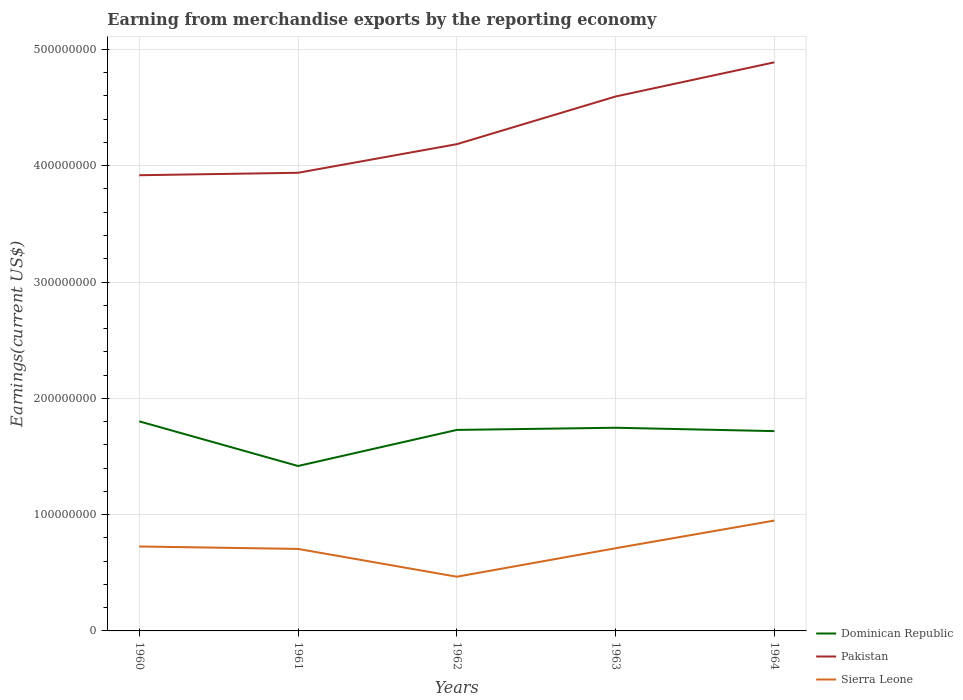How many different coloured lines are there?
Give a very brief answer. 3. Does the line corresponding to Sierra Leone intersect with the line corresponding to Pakistan?
Your response must be concise. No. Across all years, what is the maximum amount earned from merchandise exports in Sierra Leone?
Your response must be concise. 4.66e+07. In which year was the amount earned from merchandise exports in Dominican Republic maximum?
Your answer should be compact. 1961. What is the total amount earned from merchandise exports in Pakistan in the graph?
Keep it short and to the point. -2.67e+07. What is the difference between the highest and the second highest amount earned from merchandise exports in Sierra Leone?
Your response must be concise. 4.83e+07. What is the difference between the highest and the lowest amount earned from merchandise exports in Dominican Republic?
Offer a terse response. 4. Is the amount earned from merchandise exports in Dominican Republic strictly greater than the amount earned from merchandise exports in Sierra Leone over the years?
Offer a terse response. No. How many lines are there?
Offer a very short reply. 3. Does the graph contain any zero values?
Keep it short and to the point. No. How many legend labels are there?
Ensure brevity in your answer.  3. How are the legend labels stacked?
Provide a short and direct response. Vertical. What is the title of the graph?
Offer a very short reply. Earning from merchandise exports by the reporting economy. Does "Small states" appear as one of the legend labels in the graph?
Offer a very short reply. No. What is the label or title of the Y-axis?
Your answer should be very brief. Earnings(current US$). What is the Earnings(current US$) in Dominican Republic in 1960?
Your answer should be very brief. 1.80e+08. What is the Earnings(current US$) of Pakistan in 1960?
Offer a terse response. 3.92e+08. What is the Earnings(current US$) in Sierra Leone in 1960?
Make the answer very short. 7.26e+07. What is the Earnings(current US$) in Dominican Republic in 1961?
Give a very brief answer. 1.42e+08. What is the Earnings(current US$) in Pakistan in 1961?
Provide a short and direct response. 3.94e+08. What is the Earnings(current US$) of Sierra Leone in 1961?
Keep it short and to the point. 7.05e+07. What is the Earnings(current US$) of Dominican Republic in 1962?
Ensure brevity in your answer.  1.73e+08. What is the Earnings(current US$) in Pakistan in 1962?
Ensure brevity in your answer.  4.18e+08. What is the Earnings(current US$) in Sierra Leone in 1962?
Provide a short and direct response. 4.66e+07. What is the Earnings(current US$) in Dominican Republic in 1963?
Offer a very short reply. 1.75e+08. What is the Earnings(current US$) in Pakistan in 1963?
Your answer should be compact. 4.60e+08. What is the Earnings(current US$) in Sierra Leone in 1963?
Provide a short and direct response. 7.11e+07. What is the Earnings(current US$) in Dominican Republic in 1964?
Offer a terse response. 1.72e+08. What is the Earnings(current US$) in Pakistan in 1964?
Offer a terse response. 4.89e+08. What is the Earnings(current US$) of Sierra Leone in 1964?
Provide a succinct answer. 9.49e+07. Across all years, what is the maximum Earnings(current US$) in Dominican Republic?
Your response must be concise. 1.80e+08. Across all years, what is the maximum Earnings(current US$) in Pakistan?
Keep it short and to the point. 4.89e+08. Across all years, what is the maximum Earnings(current US$) in Sierra Leone?
Your answer should be compact. 9.49e+07. Across all years, what is the minimum Earnings(current US$) of Dominican Republic?
Provide a short and direct response. 1.42e+08. Across all years, what is the minimum Earnings(current US$) of Pakistan?
Your response must be concise. 3.92e+08. Across all years, what is the minimum Earnings(current US$) in Sierra Leone?
Offer a very short reply. 4.66e+07. What is the total Earnings(current US$) in Dominican Republic in the graph?
Keep it short and to the point. 8.41e+08. What is the total Earnings(current US$) in Pakistan in the graph?
Offer a very short reply. 2.15e+09. What is the total Earnings(current US$) of Sierra Leone in the graph?
Provide a succinct answer. 3.56e+08. What is the difference between the Earnings(current US$) of Dominican Republic in 1960 and that in 1961?
Ensure brevity in your answer.  3.84e+07. What is the difference between the Earnings(current US$) of Pakistan in 1960 and that in 1961?
Provide a succinct answer. -2.10e+06. What is the difference between the Earnings(current US$) in Sierra Leone in 1960 and that in 1961?
Ensure brevity in your answer.  2.10e+06. What is the difference between the Earnings(current US$) in Dominican Republic in 1960 and that in 1962?
Make the answer very short. 7.38e+06. What is the difference between the Earnings(current US$) in Pakistan in 1960 and that in 1962?
Provide a succinct answer. -2.67e+07. What is the difference between the Earnings(current US$) in Sierra Leone in 1960 and that in 1962?
Ensure brevity in your answer.  2.60e+07. What is the difference between the Earnings(current US$) of Dominican Republic in 1960 and that in 1963?
Provide a succinct answer. 5.52e+06. What is the difference between the Earnings(current US$) in Pakistan in 1960 and that in 1963?
Offer a very short reply. -6.77e+07. What is the difference between the Earnings(current US$) of Sierra Leone in 1960 and that in 1963?
Your response must be concise. 1.50e+06. What is the difference between the Earnings(current US$) in Dominican Republic in 1960 and that in 1964?
Your response must be concise. 8.41e+06. What is the difference between the Earnings(current US$) of Pakistan in 1960 and that in 1964?
Your answer should be compact. -9.71e+07. What is the difference between the Earnings(current US$) in Sierra Leone in 1960 and that in 1964?
Your answer should be very brief. -2.23e+07. What is the difference between the Earnings(current US$) in Dominican Republic in 1961 and that in 1962?
Your answer should be compact. -3.10e+07. What is the difference between the Earnings(current US$) in Pakistan in 1961 and that in 1962?
Give a very brief answer. -2.46e+07. What is the difference between the Earnings(current US$) in Sierra Leone in 1961 and that in 1962?
Ensure brevity in your answer.  2.39e+07. What is the difference between the Earnings(current US$) of Dominican Republic in 1961 and that in 1963?
Provide a short and direct response. -3.29e+07. What is the difference between the Earnings(current US$) in Pakistan in 1961 and that in 1963?
Your answer should be very brief. -6.56e+07. What is the difference between the Earnings(current US$) in Sierra Leone in 1961 and that in 1963?
Your answer should be very brief. -6.00e+05. What is the difference between the Earnings(current US$) of Dominican Republic in 1961 and that in 1964?
Make the answer very short. -3.00e+07. What is the difference between the Earnings(current US$) in Pakistan in 1961 and that in 1964?
Your answer should be compact. -9.50e+07. What is the difference between the Earnings(current US$) of Sierra Leone in 1961 and that in 1964?
Ensure brevity in your answer.  -2.44e+07. What is the difference between the Earnings(current US$) in Dominican Republic in 1962 and that in 1963?
Your response must be concise. -1.86e+06. What is the difference between the Earnings(current US$) of Pakistan in 1962 and that in 1963?
Make the answer very short. -4.10e+07. What is the difference between the Earnings(current US$) in Sierra Leone in 1962 and that in 1963?
Your answer should be compact. -2.45e+07. What is the difference between the Earnings(current US$) in Dominican Republic in 1962 and that in 1964?
Offer a very short reply. 1.03e+06. What is the difference between the Earnings(current US$) in Pakistan in 1962 and that in 1964?
Provide a short and direct response. -7.04e+07. What is the difference between the Earnings(current US$) in Sierra Leone in 1962 and that in 1964?
Provide a succinct answer. -4.83e+07. What is the difference between the Earnings(current US$) of Dominican Republic in 1963 and that in 1964?
Offer a terse response. 2.89e+06. What is the difference between the Earnings(current US$) in Pakistan in 1963 and that in 1964?
Offer a terse response. -2.94e+07. What is the difference between the Earnings(current US$) of Sierra Leone in 1963 and that in 1964?
Keep it short and to the point. -2.38e+07. What is the difference between the Earnings(current US$) in Dominican Republic in 1960 and the Earnings(current US$) in Pakistan in 1961?
Your answer should be compact. -2.14e+08. What is the difference between the Earnings(current US$) of Dominican Republic in 1960 and the Earnings(current US$) of Sierra Leone in 1961?
Offer a terse response. 1.10e+08. What is the difference between the Earnings(current US$) in Pakistan in 1960 and the Earnings(current US$) in Sierra Leone in 1961?
Provide a short and direct response. 3.21e+08. What is the difference between the Earnings(current US$) of Dominican Republic in 1960 and the Earnings(current US$) of Pakistan in 1962?
Provide a succinct answer. -2.38e+08. What is the difference between the Earnings(current US$) of Dominican Republic in 1960 and the Earnings(current US$) of Sierra Leone in 1962?
Your response must be concise. 1.34e+08. What is the difference between the Earnings(current US$) of Pakistan in 1960 and the Earnings(current US$) of Sierra Leone in 1962?
Your answer should be very brief. 3.45e+08. What is the difference between the Earnings(current US$) in Dominican Republic in 1960 and the Earnings(current US$) in Pakistan in 1963?
Ensure brevity in your answer.  -2.79e+08. What is the difference between the Earnings(current US$) in Dominican Republic in 1960 and the Earnings(current US$) in Sierra Leone in 1963?
Offer a terse response. 1.09e+08. What is the difference between the Earnings(current US$) of Pakistan in 1960 and the Earnings(current US$) of Sierra Leone in 1963?
Your answer should be very brief. 3.21e+08. What is the difference between the Earnings(current US$) in Dominican Republic in 1960 and the Earnings(current US$) in Pakistan in 1964?
Provide a succinct answer. -3.09e+08. What is the difference between the Earnings(current US$) of Dominican Republic in 1960 and the Earnings(current US$) of Sierra Leone in 1964?
Provide a short and direct response. 8.53e+07. What is the difference between the Earnings(current US$) of Pakistan in 1960 and the Earnings(current US$) of Sierra Leone in 1964?
Provide a succinct answer. 2.97e+08. What is the difference between the Earnings(current US$) in Dominican Republic in 1961 and the Earnings(current US$) in Pakistan in 1962?
Make the answer very short. -2.77e+08. What is the difference between the Earnings(current US$) in Dominican Republic in 1961 and the Earnings(current US$) in Sierra Leone in 1962?
Give a very brief answer. 9.52e+07. What is the difference between the Earnings(current US$) in Pakistan in 1961 and the Earnings(current US$) in Sierra Leone in 1962?
Make the answer very short. 3.47e+08. What is the difference between the Earnings(current US$) in Dominican Republic in 1961 and the Earnings(current US$) in Pakistan in 1963?
Provide a short and direct response. -3.18e+08. What is the difference between the Earnings(current US$) of Dominican Republic in 1961 and the Earnings(current US$) of Sierra Leone in 1963?
Offer a very short reply. 7.07e+07. What is the difference between the Earnings(current US$) of Pakistan in 1961 and the Earnings(current US$) of Sierra Leone in 1963?
Keep it short and to the point. 3.23e+08. What is the difference between the Earnings(current US$) in Dominican Republic in 1961 and the Earnings(current US$) in Pakistan in 1964?
Your answer should be very brief. -3.47e+08. What is the difference between the Earnings(current US$) in Dominican Republic in 1961 and the Earnings(current US$) in Sierra Leone in 1964?
Your answer should be compact. 4.69e+07. What is the difference between the Earnings(current US$) of Pakistan in 1961 and the Earnings(current US$) of Sierra Leone in 1964?
Provide a succinct answer. 2.99e+08. What is the difference between the Earnings(current US$) in Dominican Republic in 1962 and the Earnings(current US$) in Pakistan in 1963?
Your answer should be compact. -2.87e+08. What is the difference between the Earnings(current US$) of Dominican Republic in 1962 and the Earnings(current US$) of Sierra Leone in 1963?
Your answer should be very brief. 1.02e+08. What is the difference between the Earnings(current US$) in Pakistan in 1962 and the Earnings(current US$) in Sierra Leone in 1963?
Provide a short and direct response. 3.47e+08. What is the difference between the Earnings(current US$) in Dominican Republic in 1962 and the Earnings(current US$) in Pakistan in 1964?
Make the answer very short. -3.16e+08. What is the difference between the Earnings(current US$) of Dominican Republic in 1962 and the Earnings(current US$) of Sierra Leone in 1964?
Make the answer very short. 7.79e+07. What is the difference between the Earnings(current US$) of Pakistan in 1962 and the Earnings(current US$) of Sierra Leone in 1964?
Offer a terse response. 3.24e+08. What is the difference between the Earnings(current US$) of Dominican Republic in 1963 and the Earnings(current US$) of Pakistan in 1964?
Offer a terse response. -3.14e+08. What is the difference between the Earnings(current US$) of Dominican Republic in 1963 and the Earnings(current US$) of Sierra Leone in 1964?
Ensure brevity in your answer.  7.98e+07. What is the difference between the Earnings(current US$) of Pakistan in 1963 and the Earnings(current US$) of Sierra Leone in 1964?
Your response must be concise. 3.65e+08. What is the average Earnings(current US$) of Dominican Republic per year?
Offer a terse response. 1.68e+08. What is the average Earnings(current US$) of Pakistan per year?
Provide a short and direct response. 4.31e+08. What is the average Earnings(current US$) of Sierra Leone per year?
Provide a short and direct response. 7.11e+07. In the year 1960, what is the difference between the Earnings(current US$) in Dominican Republic and Earnings(current US$) in Pakistan?
Your response must be concise. -2.12e+08. In the year 1960, what is the difference between the Earnings(current US$) in Dominican Republic and Earnings(current US$) in Sierra Leone?
Keep it short and to the point. 1.08e+08. In the year 1960, what is the difference between the Earnings(current US$) in Pakistan and Earnings(current US$) in Sierra Leone?
Provide a short and direct response. 3.19e+08. In the year 1961, what is the difference between the Earnings(current US$) in Dominican Republic and Earnings(current US$) in Pakistan?
Your answer should be compact. -2.52e+08. In the year 1961, what is the difference between the Earnings(current US$) of Dominican Republic and Earnings(current US$) of Sierra Leone?
Offer a very short reply. 7.13e+07. In the year 1961, what is the difference between the Earnings(current US$) of Pakistan and Earnings(current US$) of Sierra Leone?
Offer a very short reply. 3.23e+08. In the year 1962, what is the difference between the Earnings(current US$) of Dominican Republic and Earnings(current US$) of Pakistan?
Your answer should be compact. -2.46e+08. In the year 1962, what is the difference between the Earnings(current US$) in Dominican Republic and Earnings(current US$) in Sierra Leone?
Provide a short and direct response. 1.26e+08. In the year 1962, what is the difference between the Earnings(current US$) of Pakistan and Earnings(current US$) of Sierra Leone?
Your response must be concise. 3.72e+08. In the year 1963, what is the difference between the Earnings(current US$) of Dominican Republic and Earnings(current US$) of Pakistan?
Offer a terse response. -2.85e+08. In the year 1963, what is the difference between the Earnings(current US$) of Dominican Republic and Earnings(current US$) of Sierra Leone?
Provide a succinct answer. 1.04e+08. In the year 1963, what is the difference between the Earnings(current US$) of Pakistan and Earnings(current US$) of Sierra Leone?
Your answer should be compact. 3.88e+08. In the year 1964, what is the difference between the Earnings(current US$) of Dominican Republic and Earnings(current US$) of Pakistan?
Your answer should be compact. -3.17e+08. In the year 1964, what is the difference between the Earnings(current US$) of Dominican Republic and Earnings(current US$) of Sierra Leone?
Make the answer very short. 7.69e+07. In the year 1964, what is the difference between the Earnings(current US$) in Pakistan and Earnings(current US$) in Sierra Leone?
Make the answer very short. 3.94e+08. What is the ratio of the Earnings(current US$) of Dominican Republic in 1960 to that in 1961?
Your answer should be very brief. 1.27. What is the ratio of the Earnings(current US$) of Pakistan in 1960 to that in 1961?
Offer a terse response. 0.99. What is the ratio of the Earnings(current US$) of Sierra Leone in 1960 to that in 1961?
Provide a short and direct response. 1.03. What is the ratio of the Earnings(current US$) of Dominican Republic in 1960 to that in 1962?
Give a very brief answer. 1.04. What is the ratio of the Earnings(current US$) in Pakistan in 1960 to that in 1962?
Give a very brief answer. 0.94. What is the ratio of the Earnings(current US$) in Sierra Leone in 1960 to that in 1962?
Ensure brevity in your answer.  1.56. What is the ratio of the Earnings(current US$) in Dominican Republic in 1960 to that in 1963?
Your response must be concise. 1.03. What is the ratio of the Earnings(current US$) of Pakistan in 1960 to that in 1963?
Offer a very short reply. 0.85. What is the ratio of the Earnings(current US$) in Sierra Leone in 1960 to that in 1963?
Offer a very short reply. 1.02. What is the ratio of the Earnings(current US$) in Dominican Republic in 1960 to that in 1964?
Give a very brief answer. 1.05. What is the ratio of the Earnings(current US$) in Pakistan in 1960 to that in 1964?
Ensure brevity in your answer.  0.8. What is the ratio of the Earnings(current US$) in Sierra Leone in 1960 to that in 1964?
Provide a succinct answer. 0.77. What is the ratio of the Earnings(current US$) in Dominican Republic in 1961 to that in 1962?
Your answer should be compact. 0.82. What is the ratio of the Earnings(current US$) in Sierra Leone in 1961 to that in 1962?
Make the answer very short. 1.51. What is the ratio of the Earnings(current US$) in Dominican Republic in 1961 to that in 1963?
Offer a terse response. 0.81. What is the ratio of the Earnings(current US$) in Pakistan in 1961 to that in 1963?
Keep it short and to the point. 0.86. What is the ratio of the Earnings(current US$) of Sierra Leone in 1961 to that in 1963?
Your response must be concise. 0.99. What is the ratio of the Earnings(current US$) of Dominican Republic in 1961 to that in 1964?
Offer a terse response. 0.83. What is the ratio of the Earnings(current US$) of Pakistan in 1961 to that in 1964?
Provide a short and direct response. 0.81. What is the ratio of the Earnings(current US$) in Sierra Leone in 1961 to that in 1964?
Your answer should be very brief. 0.74. What is the ratio of the Earnings(current US$) of Pakistan in 1962 to that in 1963?
Your answer should be very brief. 0.91. What is the ratio of the Earnings(current US$) in Sierra Leone in 1962 to that in 1963?
Your answer should be very brief. 0.66. What is the ratio of the Earnings(current US$) of Dominican Republic in 1962 to that in 1964?
Make the answer very short. 1.01. What is the ratio of the Earnings(current US$) in Pakistan in 1962 to that in 1964?
Your answer should be compact. 0.86. What is the ratio of the Earnings(current US$) in Sierra Leone in 1962 to that in 1964?
Keep it short and to the point. 0.49. What is the ratio of the Earnings(current US$) of Dominican Republic in 1963 to that in 1964?
Your response must be concise. 1.02. What is the ratio of the Earnings(current US$) in Pakistan in 1963 to that in 1964?
Your response must be concise. 0.94. What is the ratio of the Earnings(current US$) in Sierra Leone in 1963 to that in 1964?
Your answer should be compact. 0.75. What is the difference between the highest and the second highest Earnings(current US$) in Dominican Republic?
Your answer should be compact. 5.52e+06. What is the difference between the highest and the second highest Earnings(current US$) in Pakistan?
Keep it short and to the point. 2.94e+07. What is the difference between the highest and the second highest Earnings(current US$) of Sierra Leone?
Provide a short and direct response. 2.23e+07. What is the difference between the highest and the lowest Earnings(current US$) of Dominican Republic?
Give a very brief answer. 3.84e+07. What is the difference between the highest and the lowest Earnings(current US$) of Pakistan?
Offer a very short reply. 9.71e+07. What is the difference between the highest and the lowest Earnings(current US$) in Sierra Leone?
Provide a short and direct response. 4.83e+07. 